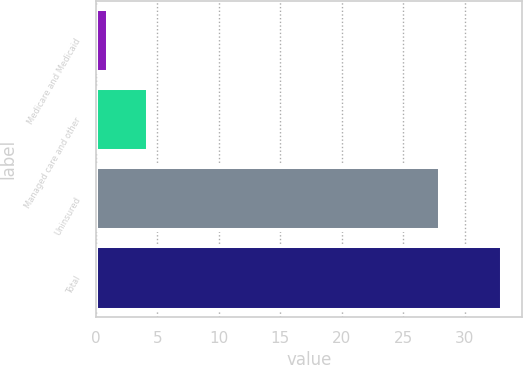<chart> <loc_0><loc_0><loc_500><loc_500><bar_chart><fcel>Medicare and Medicaid<fcel>Managed care and other<fcel>Uninsured<fcel>Total<nl><fcel>1<fcel>4.2<fcel>28<fcel>33<nl></chart> 